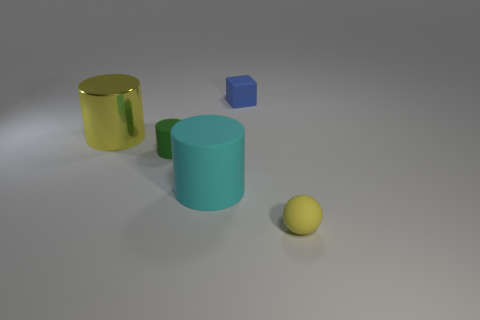What is the size of the green object that is the same shape as the large yellow shiny thing?
Offer a terse response. Small. What is the size of the matte thing that is both behind the big cyan object and to the left of the matte block?
Offer a terse response. Small. There is a tiny rubber cylinder; is its color the same as the tiny thing in front of the small matte cylinder?
Offer a very short reply. No. What number of gray things are either tiny cubes or large cylinders?
Give a very brief answer. 0. What is the shape of the large shiny object?
Make the answer very short. Cylinder. What number of other objects are there of the same shape as the big metal object?
Make the answer very short. 2. The large cylinder in front of the metal cylinder is what color?
Offer a terse response. Cyan. Are the green cylinder and the small sphere made of the same material?
Your answer should be compact. Yes. How many objects are cyan matte objects or yellow objects that are right of the green cylinder?
Provide a succinct answer. 2. What size is the ball that is the same color as the metallic cylinder?
Provide a succinct answer. Small. 